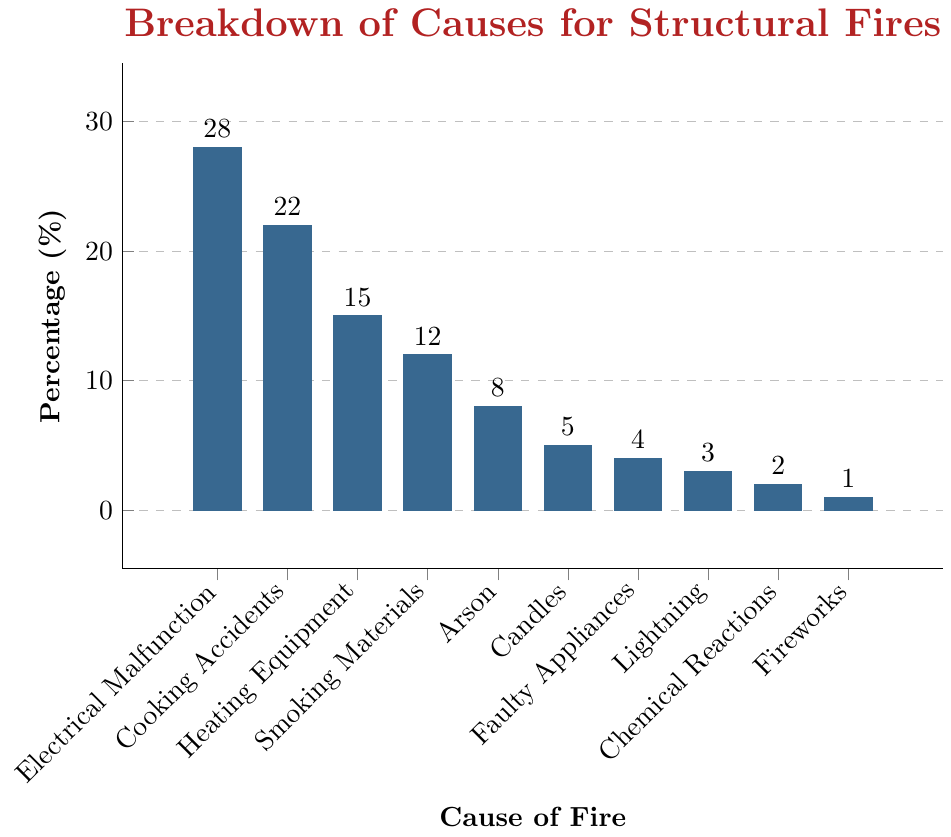Which cause has the highest percentage of structural fires according to the data? The highest bar in the figure represents Electrical Malfunction with a percentage of 28%. Identify the tallest bar and read its corresponding cause.
Answer: Electrical Malfunction Which cause accounts for the smallest percentage of structural fires? The smallest bar in the figure represents Fireworks with a percentage of 1%. Identify the shortest bar and read its corresponding cause.
Answer: Fireworks What is the total percentage of fires caused by Electrical Malfunction and Cooking Accidents combined? Electrical Malfunction accounts for 28% and Cooking Accidents for 22%. Summing them gives 28 + 22 = 50%.
Answer: 50% Which cause has a higher percentage, Smoking Materials or Heating Equipment? Compare the heights of the bars for Smoking Materials (12%) and Heating Equipment (15%). Heating Equipment has a higher percentage.
Answer: Heating Equipment How many causes have a percentage of 5% or less? Examine the bars for Candles (5%), Faulty Appliances (4%), Lightning (3%), Chemical Reactions (2%), and Fireworks (1%). Count these bars to get a total of 5 causes.
Answer: 5 What is the percentage difference between Arson and Cooking Accidents? Arson accounts for 8% and Cooking Accidents for 22%. The difference is 22 - 8 = 14%.
Answer: 14% If you sum the percentages of faults related to electrical issues (Electrical Malfunction and Faulty Appliances), what do you get? Electrical Malfunction is 28% and Faulty Appliances is 4%. Summing them gives 28 + 4 = 32%.
Answer: 32% Are there more causes with a percentage above or below 10%? Causes above 10% are Electrical Malfunction, Cooking Accidents, Heating Equipment, and Smoking Materials (4 causes). Causes below 10% are Arson, Candles, Faulty Appliances, Lightning, Chemical Reactions, and Fireworks (6 causes). There are more below 10%.
Answer: Below Which two causes combined account for almost half of the structural fire causes? Electrical Malfunction (28%) and Cooking Accidents (22%) together account for 28 + 22 = 50%, which is half.
Answer: Electrical Malfunction and Cooking Accidents What visual characteristic helps you quickly identify the cause with the smallest percentage? The shortest bar in the chart visually indicates the smallest percentage.
Answer: The shortest bar 